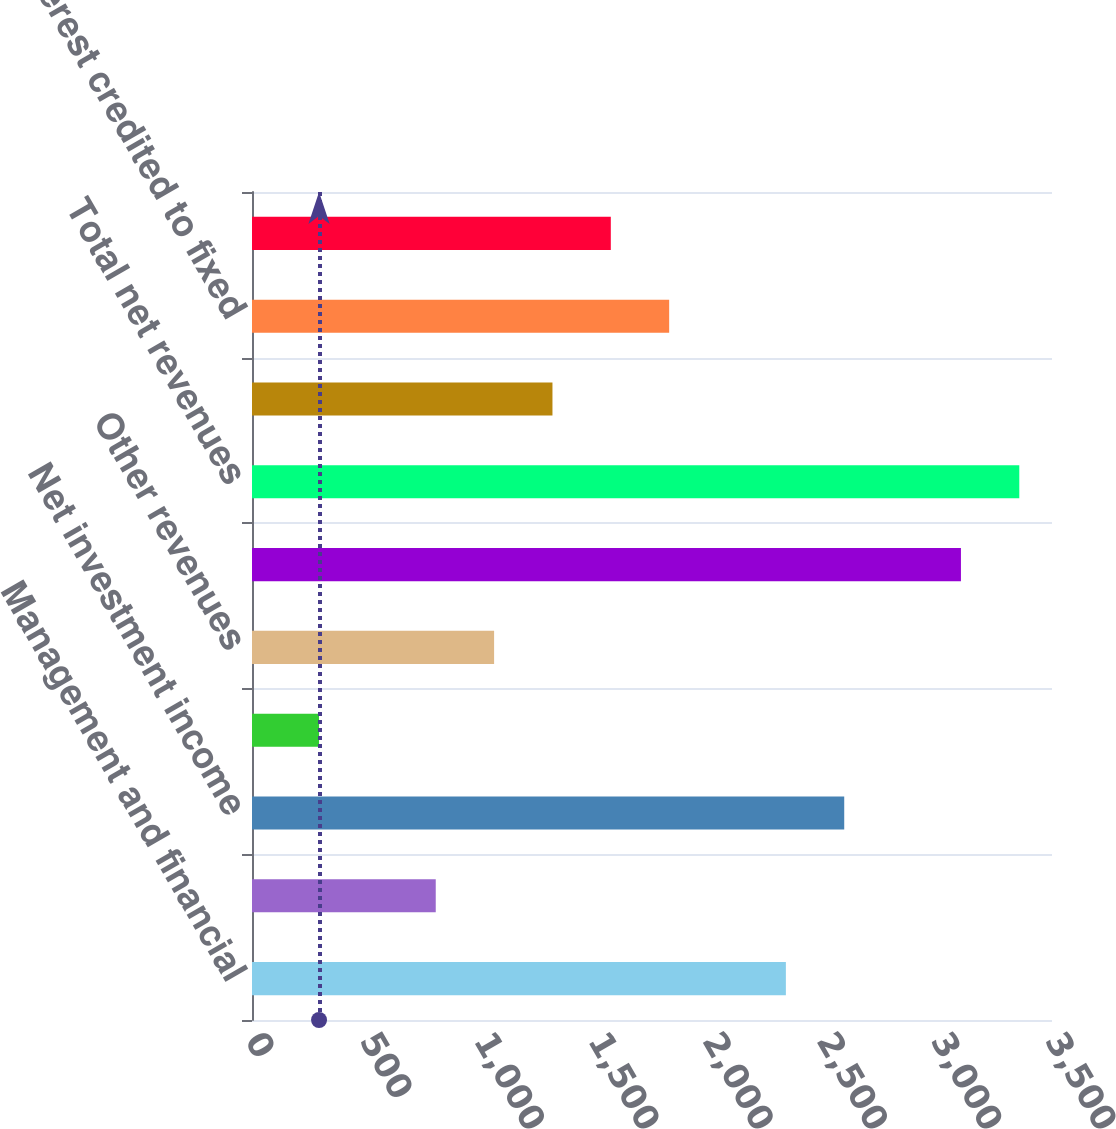Convert chart. <chart><loc_0><loc_0><loc_500><loc_500><bar_chart><fcel>Management and financial<fcel>Distribution fees<fcel>Net investment income<fcel>Premiums<fcel>Other revenues<fcel>Total revenues<fcel>Total net revenues<fcel>Distribution expenses<fcel>Interest credited to fixed<fcel>Benefits claims losses and<nl><fcel>2335.7<fcel>803.9<fcel>2591<fcel>293.3<fcel>1059.2<fcel>3101.6<fcel>3356.9<fcel>1314.5<fcel>1825.1<fcel>1569.8<nl></chart> 